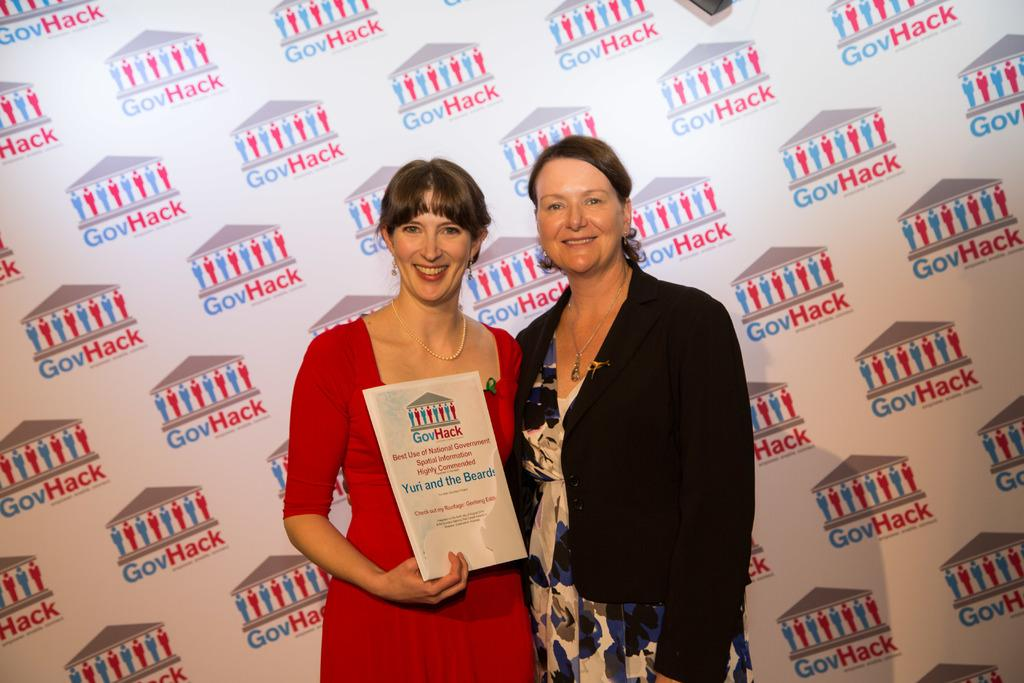How many people are in the image? There are two women in the image. Where are the women located in the image? The women are standing in the middle of the image. What is the woman on the left side holding? The woman on the left side is holding a book. What can be seen in the background of the image? There is a board visible in the background of the image. What type of clouds can be seen in the image? There are no clouds visible in the image; it features two women standing in the middle of the image with a board in the background. What shape is the book held by the woman on the left side? The provided facts do not mention the shape of the book, only that it is being held by the woman on the left side. 